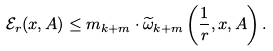<formula> <loc_0><loc_0><loc_500><loc_500>\mathcal { E } _ { r } ( x , A ) \leq m _ { k + m } \cdot \widetilde { \omega } _ { k + m } \left ( \frac { 1 } { r } , x , A \right ) .</formula> 